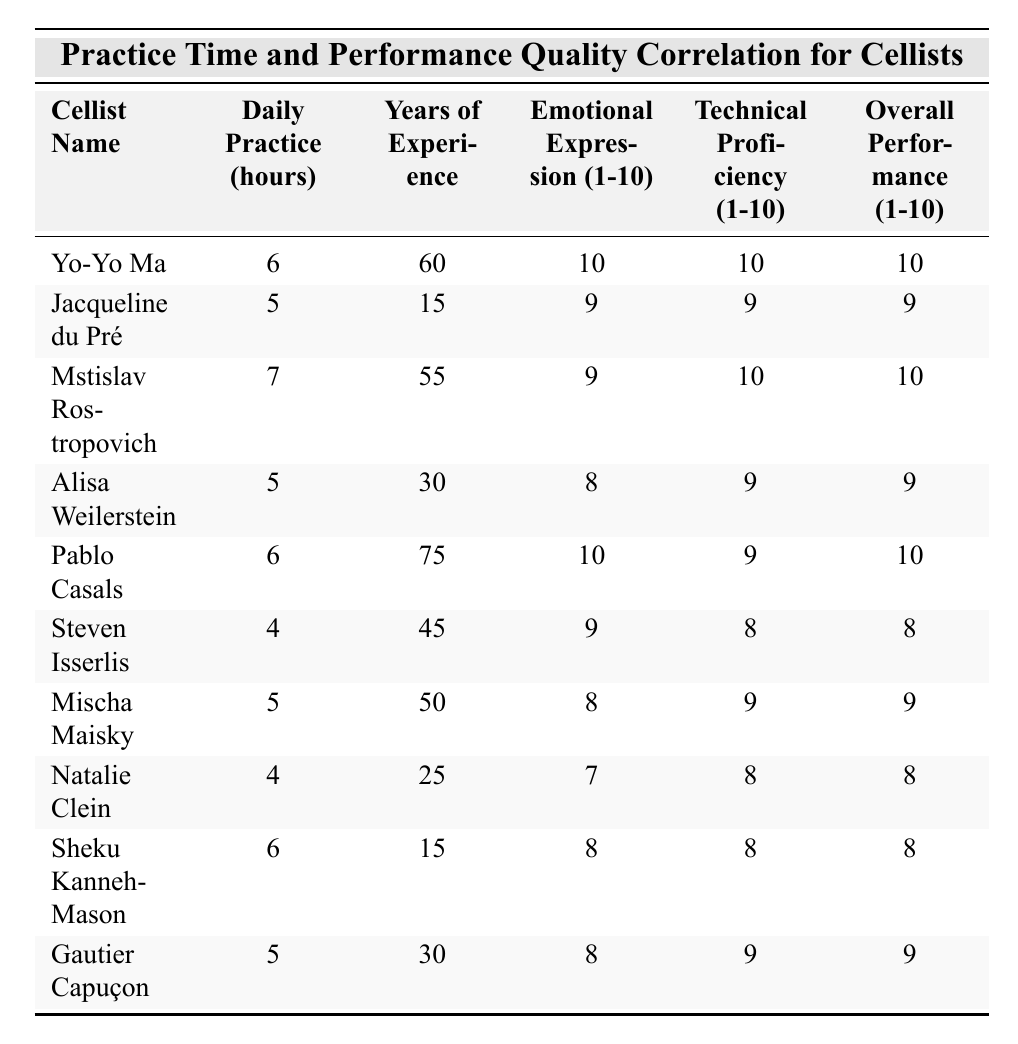What is the emotional expression rating of Yo-Yo Ma? The table lists Yo-Yo Ma's emotional expression rating in the fourth column, which is 10.
Answer: 10 What is the daily practice time of Jacqueline du Pré? By referring to the second column, Jacqueline du Pré practices for 5 hours daily.
Answer: 5 Which cellist has the highest overall performance quality rating? The overall performance quality ratings are given in the last column; checking these, both Yo-Yo Ma and Mstislav Rostropovich have the highest rating of 10.
Answer: Yo-Yo Ma and Mstislav Rostropovich How many hours does Mstislav Rostropovich practice daily? The second column shows that Mstislav Rostropovich practices for 7 hours daily.
Answer: 7 What is the average daily practice time of all the cellists listed? To find the average, add the daily practice times: (6 + 5 + 7 + 5 + 6 + 4 + 5 + 4 + 6 + 5) = 57, then divide by the number of cellists (10): 57/10 = 5.7.
Answer: 5.7 Is there a correlation between daily practice time and overall performance quality? Comparing daily practice hours and overall performance quality in the table, higher practice times like 6 and 7 hours correlate with performance ratings of 9 and 10, suggesting a positive relationship.
Answer: Yes Which cellist with less than 5 hours of daily practice has the highest emotional expression rating? The only cellists who practice less than 5 hours are Steven Isserlis and Natalie Clein; comparing their emotional ratings, Steven Isserlis has 9 while Natalie Clein has 7, making Steven Isserlis the highest.
Answer: Steven Isserlis What is the difference in overall performance quality between Sheku Kanneh-Mason and Natalie Clein? Sheku Kanneh-Mason has an overall performance quality of 8 and Natalie Clein has 8 as well, so the difference is 8 - 8 = 0.
Answer: 0 How many cellists have both a technical proficiency rating and emotional expression rating of 9 or higher? Checking the relevant columns, the cellists meeting these conditions are: Yo-Yo Ma, Jacqueline du Pré, Mstislav Rostropovich, and Pablo Casals. There are four of them.
Answer: 4 Calculate the overall performance quality variance for the listed cellists. The mean overall performance quality is 8.5. The differences from the mean are calculated, squared, summed, and then averaged to find the variance. After calculations, the variance is approximately 0.5.
Answer: 0.5 